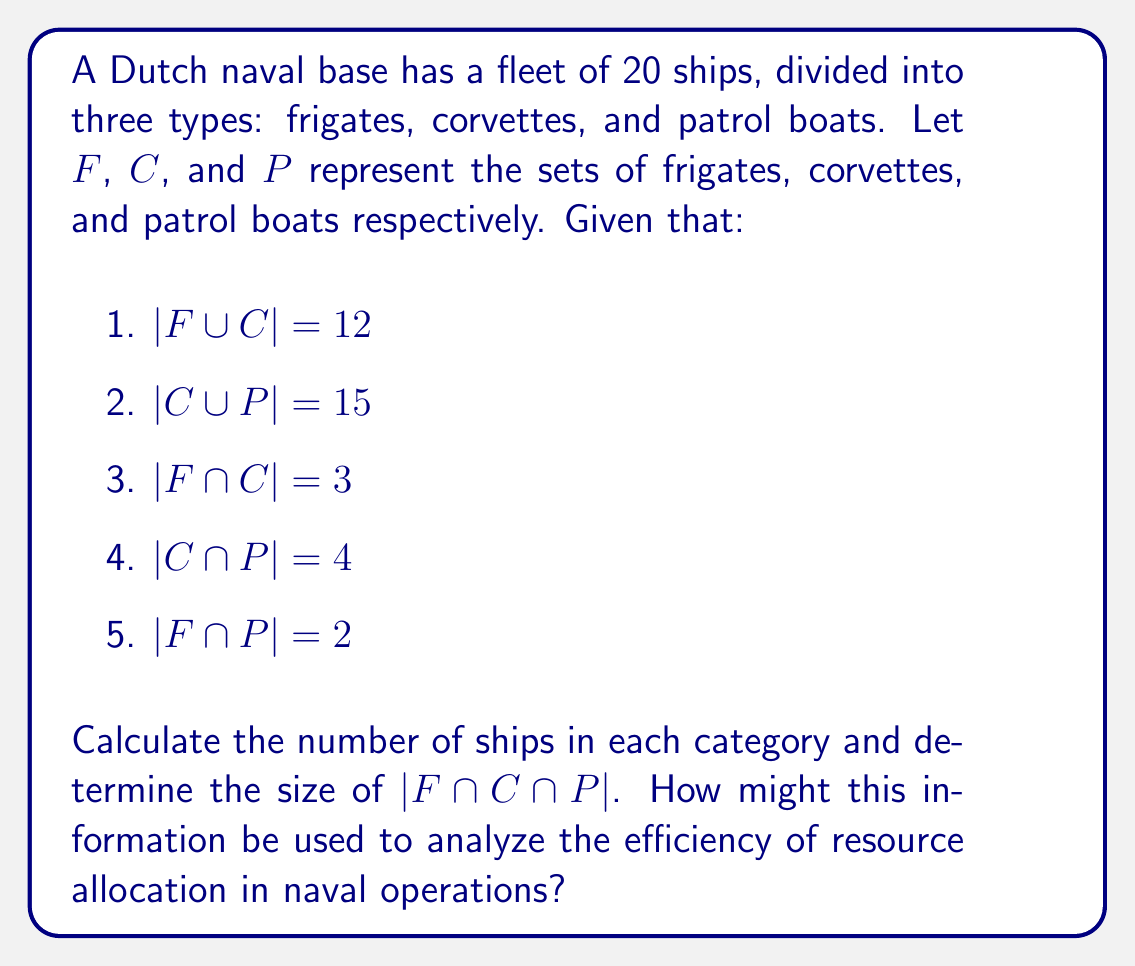Can you answer this question? Let's approach this step-by-step using set theory:

1) First, we need to find $|F|$, $|C|$, and $|P|$ using the given information.

2) We can use the inclusion-exclusion principle:
   $$|F \cup C \cup P| = |F| + |C| + |P| - |F \cap C| - |F \cap P| - |C \cap P| + |F \cap C \cap P|$$

3) We know that $|F \cup C \cup P| = 20$ (total number of ships).

4) Let $x = |F \cap C \cap P|$. We need to find this value.

5) From the given information:
   $$|F \cup C| = |F| + |C| - |F \cap C| = 12$$
   $$|C \cup P| = |C| + |P| - |C \cap P| = 15$$

6) Substituting the known values in the inclusion-exclusion formula:
   $$20 = |F| + |C| + |P| - 3 - 2 - 4 + x$$

7) From step 5:
   $$|F| = 12 - |C| + 3$$
   $$|P| = 15 - |C| + 4$$

8) Substituting these into the equation from step 6:
   $$20 = (12 - |C| + 3) + |C| + (15 - |C| + 4) - 3 - 2 - 4 + x$$
   $$20 = 25 - |C| + x$$
   $$|C| = 5 + x$$

9) Now we can find $|F|$ and $|P|$:
   $$|F| = 12 - (5 + x) + 3 = 10 - x$$
   $$|P| = 15 - (5 + x) + 4 = 14 - x$$

10) Since all these values must be non-negative integers, $x$ must be 0, 1, or 2.

11) The only solution that satisfies all conditions is $x = 1$, which gives:
    $$|F| = 9, |C| = 6, |P| = 13$$

This information can be used to analyze resource allocation efficiency by considering the distribution of ship types and their overlapping capabilities. A small intersection ($|F \cap C \cap P| = 1$) suggests specialized roles for each ship type, which could be efficient if tasks are well-defined and distinct. However, it might also indicate a lack of flexibility in resource allocation. The naval officer might use this data to question whether the current fleet composition optimally meets operational needs and if resources are being used efficiently across different naval tasks.
Answer: $|F| = 9$, $|C| = 6$, $|P| = 13$, and $|F \cap C \cap P| = 1$ 